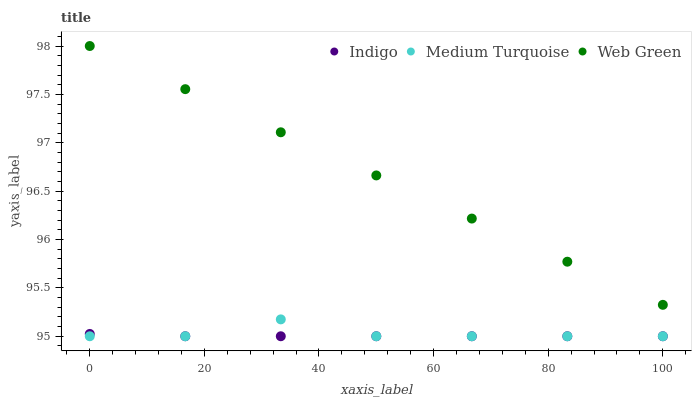Does Indigo have the minimum area under the curve?
Answer yes or no. Yes. Does Web Green have the maximum area under the curve?
Answer yes or no. Yes. Does Medium Turquoise have the minimum area under the curve?
Answer yes or no. No. Does Medium Turquoise have the maximum area under the curve?
Answer yes or no. No. Is Web Green the smoothest?
Answer yes or no. Yes. Is Medium Turquoise the roughest?
Answer yes or no. Yes. Is Medium Turquoise the smoothest?
Answer yes or no. No. Is Web Green the roughest?
Answer yes or no. No. Does Indigo have the lowest value?
Answer yes or no. Yes. Does Web Green have the lowest value?
Answer yes or no. No. Does Web Green have the highest value?
Answer yes or no. Yes. Does Medium Turquoise have the highest value?
Answer yes or no. No. Is Medium Turquoise less than Web Green?
Answer yes or no. Yes. Is Web Green greater than Indigo?
Answer yes or no. Yes. Does Indigo intersect Medium Turquoise?
Answer yes or no. Yes. Is Indigo less than Medium Turquoise?
Answer yes or no. No. Is Indigo greater than Medium Turquoise?
Answer yes or no. No. Does Medium Turquoise intersect Web Green?
Answer yes or no. No. 